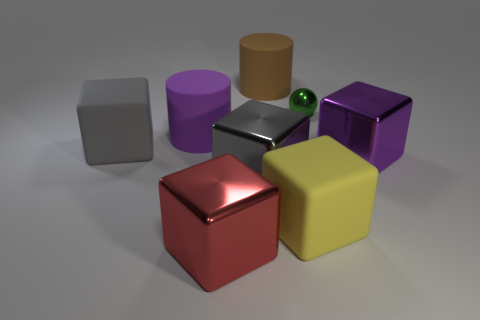Is the number of green shiny balls greater than the number of gray things?
Your answer should be compact. No. What number of big shiny things are there?
Give a very brief answer. 3. What is the shape of the large purple thing in front of the large cylinder that is to the left of the big object that is in front of the yellow rubber block?
Provide a short and direct response. Cube. Is the number of big blocks to the left of the large yellow block less than the number of big gray blocks in front of the small metallic thing?
Provide a short and direct response. No. Do the brown object behind the tiny green shiny sphere and the large metal thing right of the brown matte thing have the same shape?
Ensure brevity in your answer.  No. There is a large rubber object that is on the right side of the matte cylinder behind the tiny green metal sphere; what shape is it?
Offer a very short reply. Cube. Are there any tiny blue things that have the same material as the green ball?
Provide a succinct answer. No. What material is the large gray block that is behind the gray metal thing?
Keep it short and to the point. Rubber. What is the material of the tiny green sphere?
Your answer should be compact. Metal. Is the material of the big purple thing in front of the gray matte block the same as the tiny green sphere?
Provide a short and direct response. Yes. 